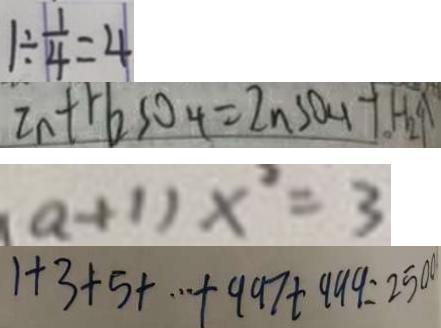<formula> <loc_0><loc_0><loc_500><loc_500>1 \div \frac { 1 } { 4 } = 4 
 Z n + H _ { 2 } S O _ { 4 } = Z n S O _ { 4 } + H _ { 2 } \uparrow 
 ( a + 1 ) x ^ { 2 } = 3 
 1 + 3 + 5 + \cdots + 9 9 7 + 9 9 9 = 2 5 0 0</formula> 